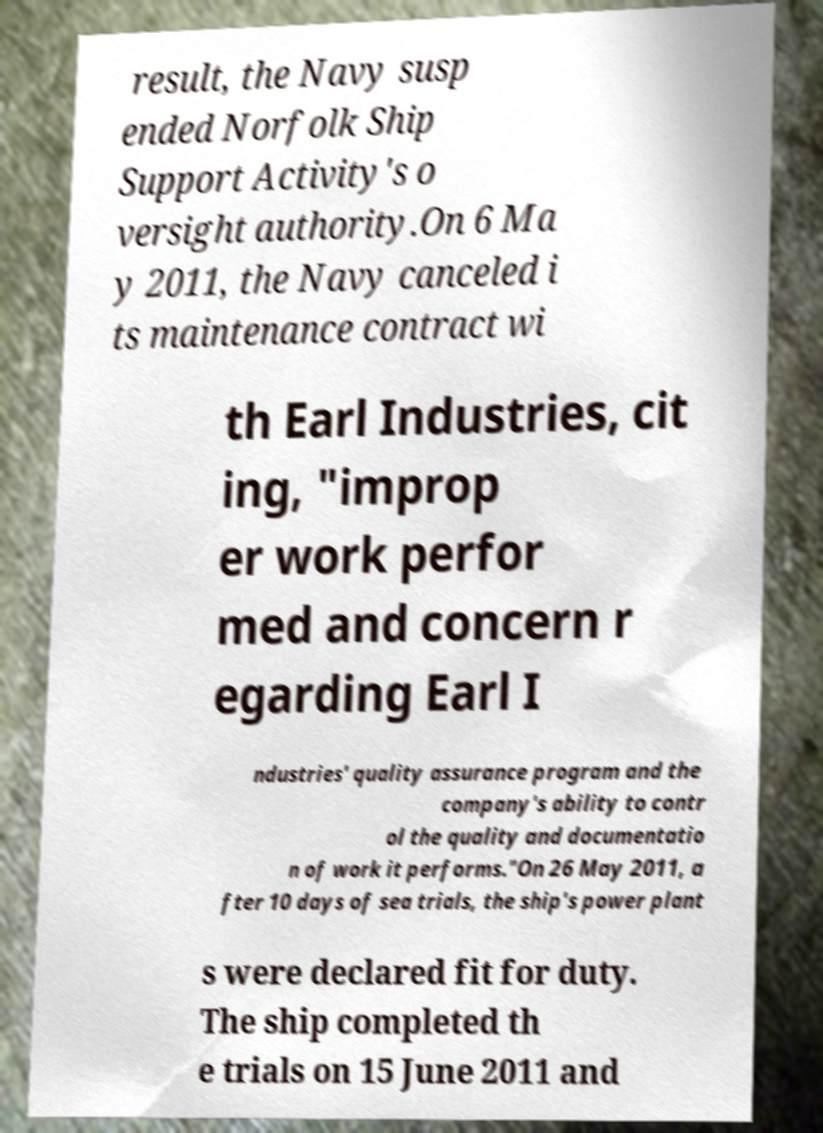For documentation purposes, I need the text within this image transcribed. Could you provide that? result, the Navy susp ended Norfolk Ship Support Activity's o versight authority.On 6 Ma y 2011, the Navy canceled i ts maintenance contract wi th Earl Industries, cit ing, "improp er work perfor med and concern r egarding Earl I ndustries' quality assurance program and the company's ability to contr ol the quality and documentatio n of work it performs."On 26 May 2011, a fter 10 days of sea trials, the ship's power plant s were declared fit for duty. The ship completed th e trials on 15 June 2011 and 